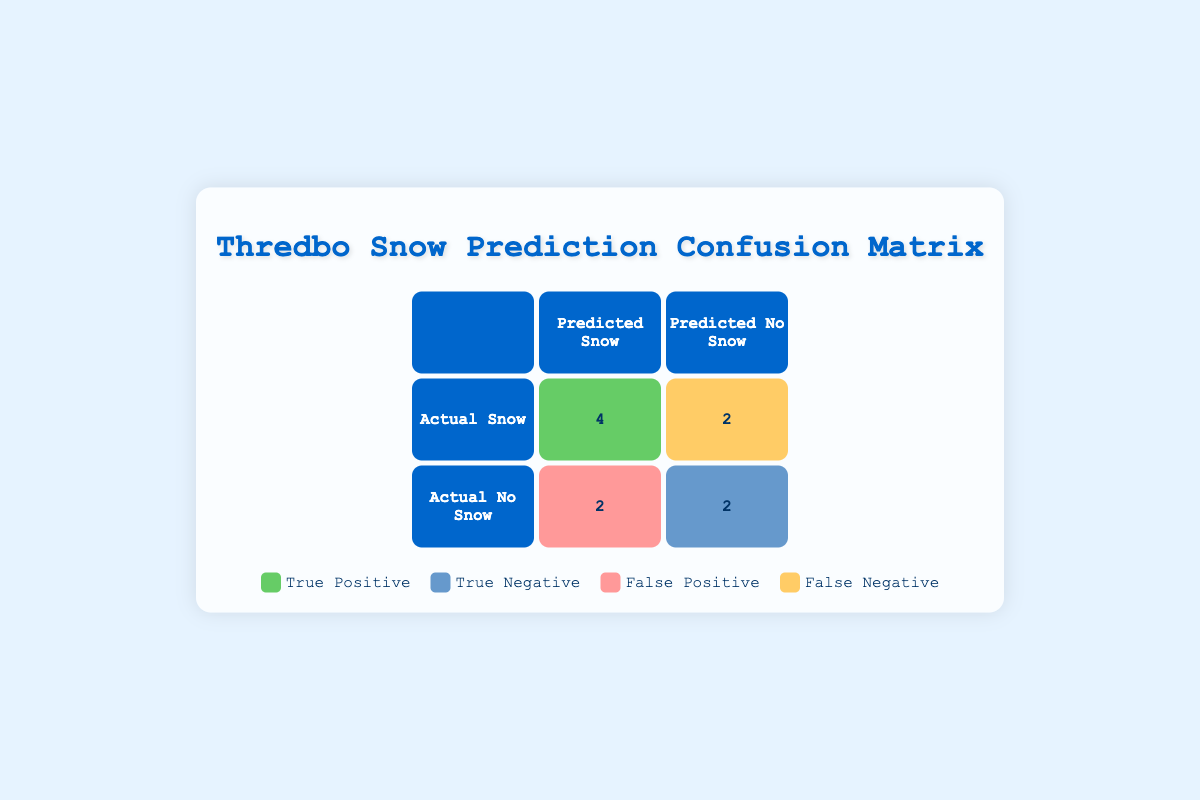What is the total number of True Positives in the table? There are 4 instances labeled as True Positive in the table, specifically on dates: 2023-06-01, 2023-06-05, 2023-06-06, and 2023-06-08.
Answer: 4 How many days had False Negatives? There are 2 entries labeled as False Negative in the table, occurring on 2023-06-04 and 2023-06-09.
Answer: 2 What is the total count of snow predictions that were correct? To calculate this, we add the True Positives (4) and True Negatives (2) together. Correct predictions total = 4 (True Positives) + 2 (True Negatives) = 6.
Answer: 6 Did the model incorrectly predict snow on 2023-06-03? Yes, on 2023-06-03, the model predicted snow, but the actual outcome was no snow, which is classified as a False Positive.
Answer: Yes Which date had a False Negative prediction? The dates with False Negative predictions are 2023-06-04 and 2023-06-09.
Answer: 2023-06-04 and 2023-06-09 What is the difference between True Positives and False Positives? True Positives are the correct predictions of snow, which count to 4, while False Positives, where snow was predicted but did not occur, count to 2. Therefore, the difference is 4 - 2 = 2.
Answer: 2 How many total predictions were made in the table? To find the total predictions, we count all entries in the table, which are 10, from dates 2023-06-01 to 2023-06-10.
Answer: 10 Is there an equal number of True Negatives and False Positives? No, there are 2 True Negatives and 2 False Positives, which means they are equal in number.
Answer: Yes What percentage of the total predictions were True Negatives? To find the percentage, we use the formula: (True Negatives / Total Predictions) * 100. Here, (2 / 10) * 100 = 20%.
Answer: 20% 